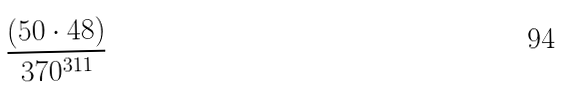Convert formula to latex. <formula><loc_0><loc_0><loc_500><loc_500>\frac { ( 5 0 \cdot 4 8 ) } { 3 7 0 ^ { 3 1 1 } }</formula> 